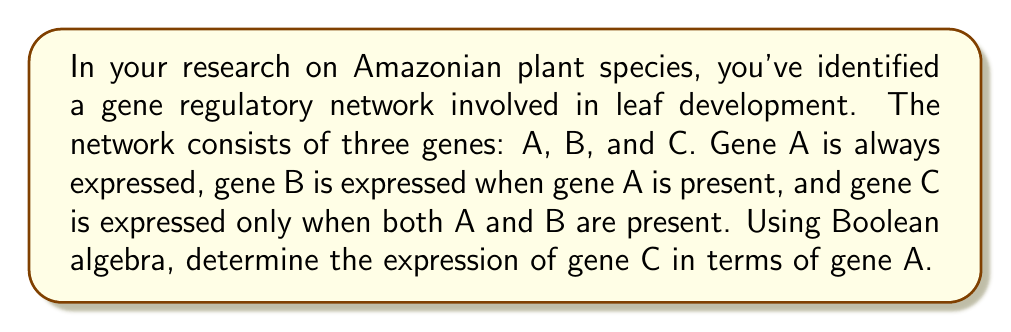Help me with this question. Let's approach this step-by-step using Boolean algebra:

1) First, let's define our variables:
   $A$ = expression of gene A
   $B$ = expression of gene B
   $C$ = expression of gene C

2) We're given that gene A is always expressed, so:
   $A = 1$

3) Gene B is expressed when gene A is present:
   $B = A$

4) Gene C is expressed only when both A and B are present:
   $C = A \cdot B$

5) Now, let's substitute the expression for B into the equation for C:
   $C = A \cdot (A)$

6) In Boolean algebra, $A \cdot A = A$ (idempotent law), so:
   $C = A$

7) We know that $A = 1$, so we can conclude:
   $C = 1$

Therefore, gene C will always be expressed, just like gene A.
Answer: $C = 1$ 